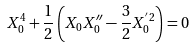<formula> <loc_0><loc_0><loc_500><loc_500>X _ { 0 } ^ { 4 } + \frac { 1 } { 2 } \left ( X _ { 0 } X ^ { \prime \prime } _ { 0 } - \frac { 3 } { 2 } X _ { 0 } ^ { ^ { \prime } 2 } \right ) = 0</formula> 